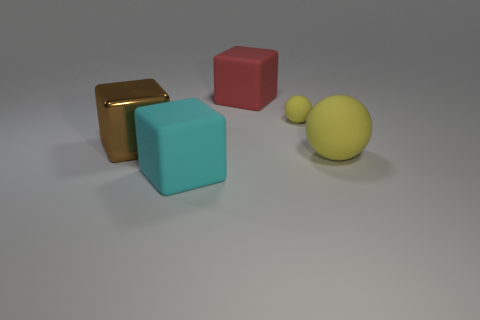What is the color of the matte sphere that is the same size as the metal block?
Provide a short and direct response. Yellow. What is the shape of the big object behind the large thing that is left of the big cyan thing?
Ensure brevity in your answer.  Cube. Do the yellow thing in front of the brown object and the tiny matte sphere have the same size?
Make the answer very short. No. What number of other objects are there of the same material as the brown block?
Keep it short and to the point. 0. What number of brown things are either large rubber blocks or big matte spheres?
Give a very brief answer. 0. There is a thing that is the same color as the large rubber sphere; what is its size?
Your answer should be very brief. Small. There is a small yellow rubber object; what number of red objects are behind it?
Your answer should be very brief. 1. What size is the matte thing left of the big red block that is behind the ball that is behind the brown shiny object?
Provide a short and direct response. Large. Are there any large red things on the left side of the rubber object that is left of the red matte cube that is behind the large cyan rubber block?
Your response must be concise. No. Is the number of blue metallic spheres greater than the number of tiny rubber objects?
Offer a very short reply. No. 